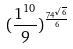<formula> <loc_0><loc_0><loc_500><loc_500>( \frac { 1 ^ { 1 0 } } { 9 } ) ^ { \frac { 7 4 ^ { \sqrt { 6 } } } { 6 } }</formula> 